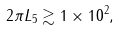<formula> <loc_0><loc_0><loc_500><loc_500>2 \pi L _ { 5 } \gtrsim 1 \times 1 0 ^ { 2 } ,</formula> 